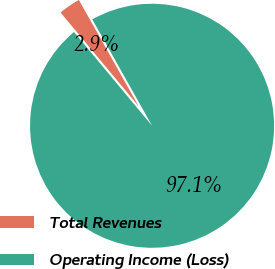Convert chart to OTSL. <chart><loc_0><loc_0><loc_500><loc_500><pie_chart><fcel>Total Revenues<fcel>Operating Income (Loss)<nl><fcel>2.9%<fcel>97.1%<nl></chart> 